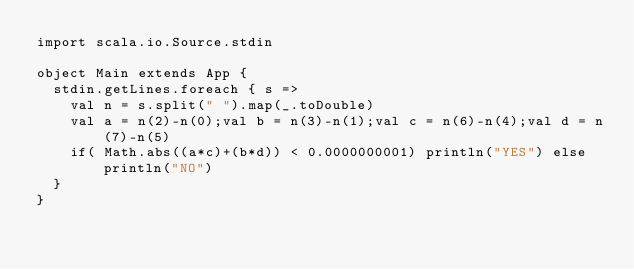<code> <loc_0><loc_0><loc_500><loc_500><_Scala_>import scala.io.Source.stdin

object Main extends App {
  stdin.getLines.foreach { s =>
    val n = s.split(" ").map(_.toDouble)
    val a = n(2)-n(0);val b = n(3)-n(1);val c = n(6)-n(4);val d = n(7)-n(5)
    if( Math.abs((a*c)+(b*d)) < 0.0000000001) println("YES") else println("NO")
  }
}</code> 